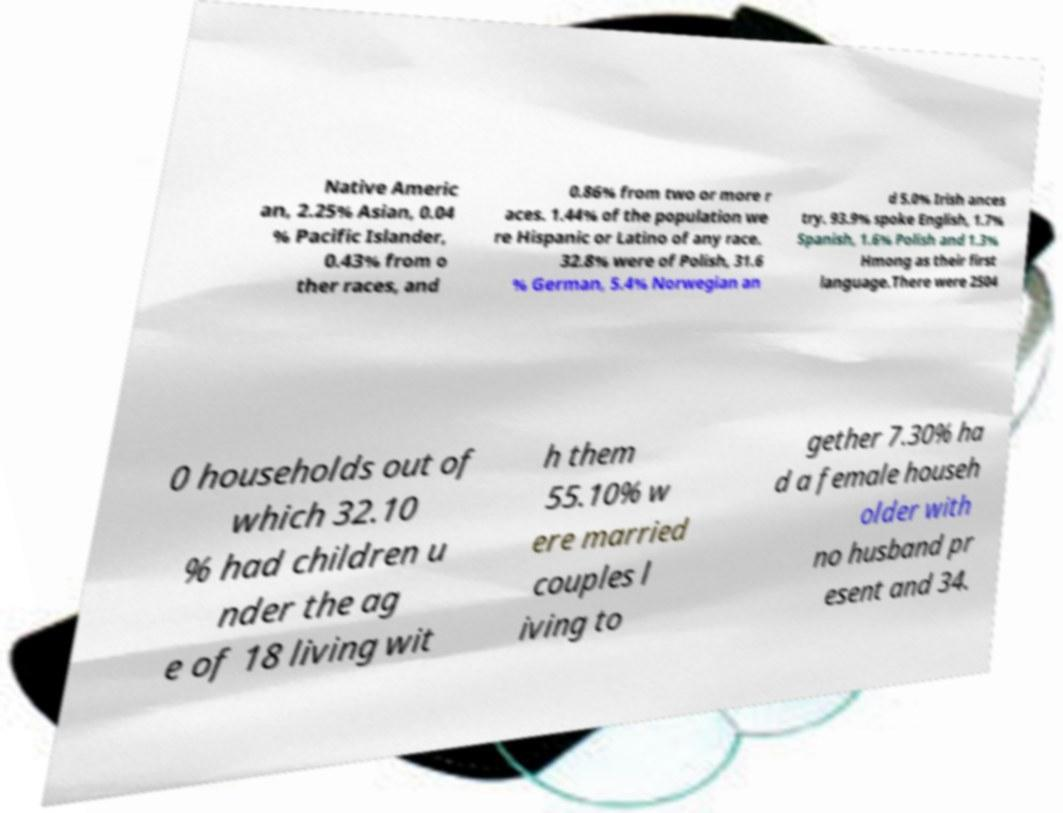What messages or text are displayed in this image? I need them in a readable, typed format. Native Americ an, 2.25% Asian, 0.04 % Pacific Islander, 0.43% from o ther races, and 0.86% from two or more r aces. 1.44% of the population we re Hispanic or Latino of any race. 32.8% were of Polish, 31.6 % German, 5.4% Norwegian an d 5.0% Irish ances try. 93.9% spoke English, 1.7% Spanish, 1.6% Polish and 1.3% Hmong as their first language.There were 2504 0 households out of which 32.10 % had children u nder the ag e of 18 living wit h them 55.10% w ere married couples l iving to gether 7.30% ha d a female househ older with no husband pr esent and 34. 